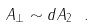<formula> <loc_0><loc_0><loc_500><loc_500>A _ { \perp } \sim d A _ { 2 } \ .</formula> 